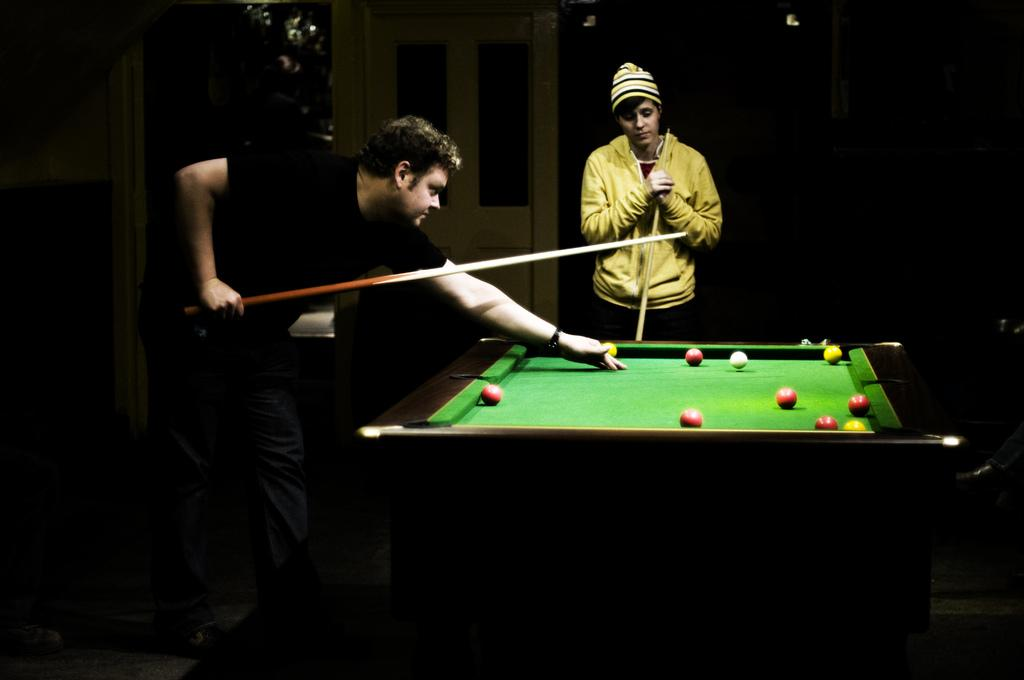What is the man on the left side of the image doing? The man is holding a snooker stick and playing a snooker game. Who else is present in the image? There is a person standing in the center of the image. What is the person in the center doing? The person in the center is watching the snooker game. What route does the stone take while being thrown by the person in the image? There is no stone being thrown in the image; the man is playing snooker and the person in the center is watching the game. 